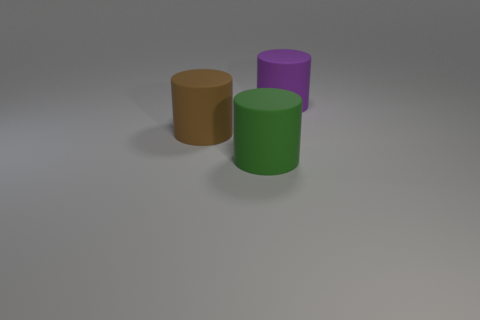The large brown object that is on the left side of the big green thing has what shape?
Provide a succinct answer. Cylinder. What is the shape of the brown thing that is the same size as the green object?
Ensure brevity in your answer.  Cylinder. There is a large matte cylinder in front of the rubber cylinder that is to the left of the large thing that is in front of the brown thing; what is its color?
Your answer should be compact. Green. Does the brown object have the same shape as the green object?
Keep it short and to the point. Yes. Is the number of green rubber cylinders on the right side of the purple matte cylinder the same as the number of large yellow matte cylinders?
Offer a very short reply. Yes. What number of other objects are there of the same material as the big purple cylinder?
Offer a terse response. 2. There is a rubber cylinder to the right of the green cylinder; does it have the same size as the rubber thing that is in front of the brown matte cylinder?
Offer a terse response. Yes. What number of objects are big things that are behind the green rubber cylinder or large matte things left of the purple matte thing?
Provide a succinct answer. 3. Is there any other thing that has the same shape as the purple thing?
Your answer should be very brief. Yes. There is a large object that is to the left of the large green thing; is it the same color as the big thing that is on the right side of the large green thing?
Ensure brevity in your answer.  No. 